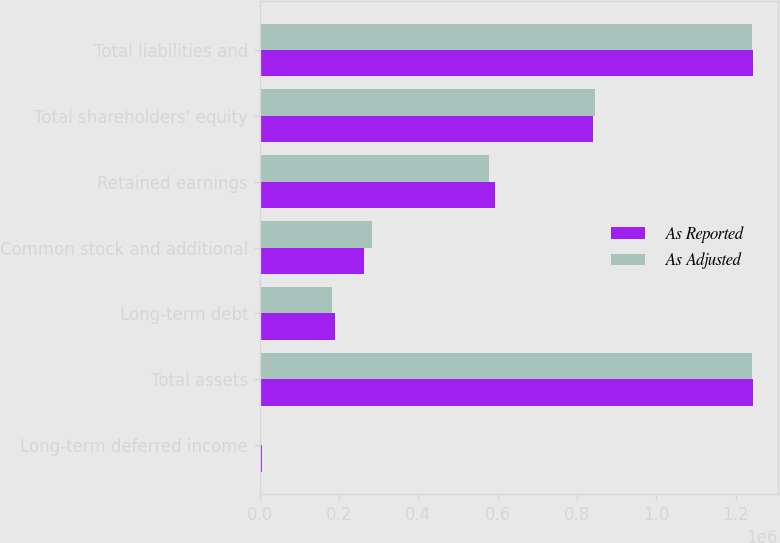<chart> <loc_0><loc_0><loc_500><loc_500><stacked_bar_chart><ecel><fcel>Long-term deferred income<fcel>Total assets<fcel>Long-term debt<fcel>Common stock and additional<fcel>Retained earnings<fcel>Total shareholders' equity<fcel>Total liabilities and<nl><fcel>As Reported<fcel>5047<fcel>1.24391e+06<fcel>190318<fcel>262509<fcel>592766<fcel>840062<fcel>1.24391e+06<nl><fcel>As Adjusted<fcel>2217<fcel>1.24108e+06<fcel>182825<fcel>282849<fcel>577090<fcel>844725<fcel>1.24108e+06<nl></chart> 